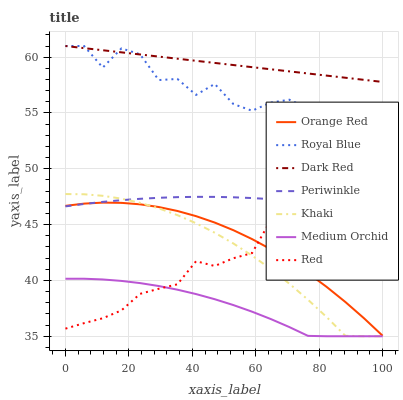Does Medium Orchid have the minimum area under the curve?
Answer yes or no. Yes. Does Dark Red have the maximum area under the curve?
Answer yes or no. Yes. Does Dark Red have the minimum area under the curve?
Answer yes or no. No. Does Medium Orchid have the maximum area under the curve?
Answer yes or no. No. Is Dark Red the smoothest?
Answer yes or no. Yes. Is Royal Blue the roughest?
Answer yes or no. Yes. Is Medium Orchid the smoothest?
Answer yes or no. No. Is Medium Orchid the roughest?
Answer yes or no. No. Does Khaki have the lowest value?
Answer yes or no. Yes. Does Dark Red have the lowest value?
Answer yes or no. No. Does Royal Blue have the highest value?
Answer yes or no. Yes. Does Medium Orchid have the highest value?
Answer yes or no. No. Is Red less than Dark Red?
Answer yes or no. Yes. Is Royal Blue greater than Medium Orchid?
Answer yes or no. Yes. Does Khaki intersect Medium Orchid?
Answer yes or no. Yes. Is Khaki less than Medium Orchid?
Answer yes or no. No. Is Khaki greater than Medium Orchid?
Answer yes or no. No. Does Red intersect Dark Red?
Answer yes or no. No. 